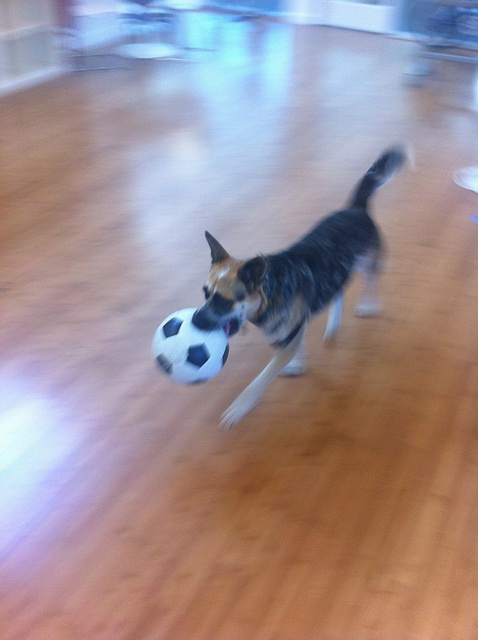Describe the objects in this image and their specific colors. I can see dog in gray, navy, and black tones, sports ball in gray and lightblue tones, and frisbee in gray, lightblue, and darkgray tones in this image. 